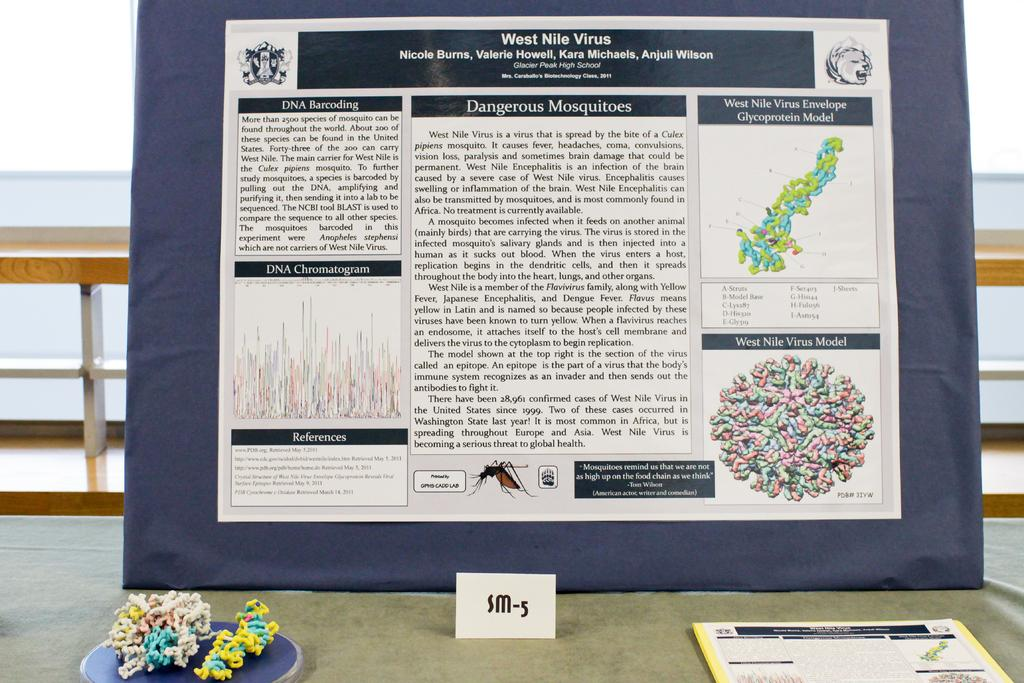<image>
Write a terse but informative summary of the picture. Information about West Nile virus on a board set up on a table. 